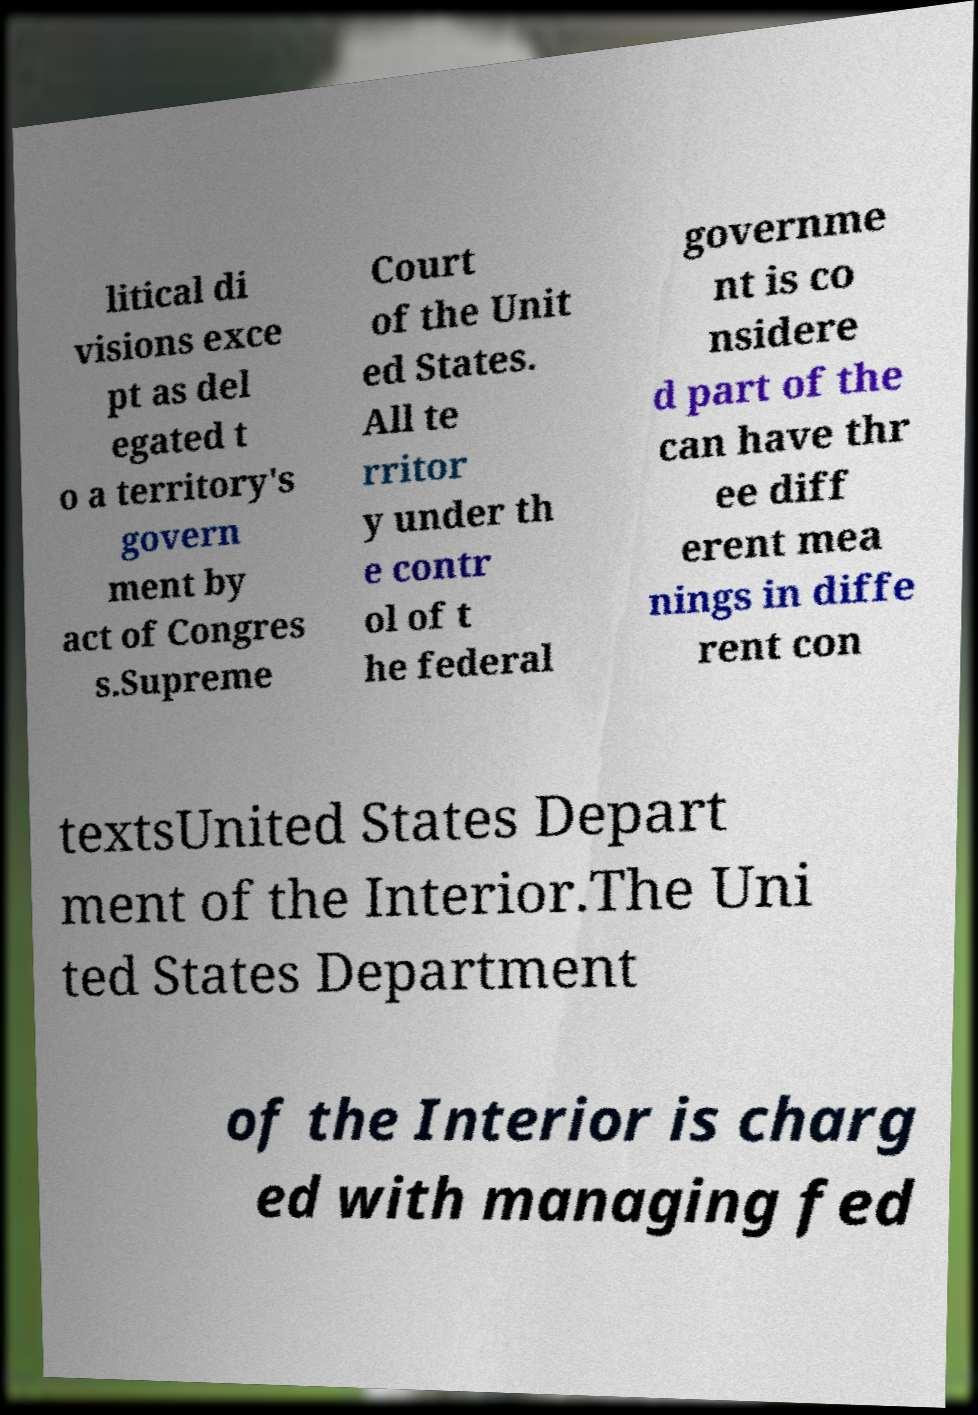Please identify and transcribe the text found in this image. litical di visions exce pt as del egated t o a territory's govern ment by act of Congres s.Supreme Court of the Unit ed States. All te rritor y under th e contr ol of t he federal governme nt is co nsidere d part of the can have thr ee diff erent mea nings in diffe rent con textsUnited States Depart ment of the Interior.The Uni ted States Department of the Interior is charg ed with managing fed 